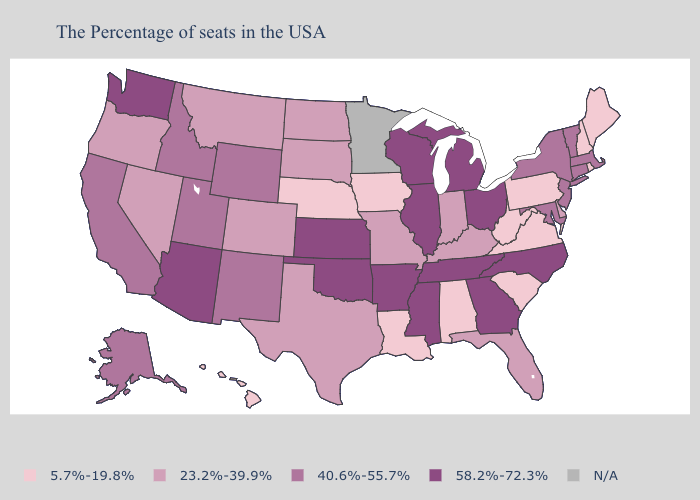Does Wyoming have the lowest value in the USA?
Give a very brief answer. No. Name the states that have a value in the range 5.7%-19.8%?
Give a very brief answer. Maine, Rhode Island, New Hampshire, Pennsylvania, Virginia, South Carolina, West Virginia, Alabama, Louisiana, Iowa, Nebraska, Hawaii. Among the states that border Arkansas , does Louisiana have the lowest value?
Short answer required. Yes. Is the legend a continuous bar?
Keep it brief. No. What is the value of Wisconsin?
Quick response, please. 58.2%-72.3%. What is the value of Utah?
Write a very short answer. 40.6%-55.7%. Name the states that have a value in the range N/A?
Short answer required. Minnesota. What is the value of Maine?
Concise answer only. 5.7%-19.8%. Which states have the highest value in the USA?
Concise answer only. North Carolina, Ohio, Georgia, Michigan, Tennessee, Wisconsin, Illinois, Mississippi, Arkansas, Kansas, Oklahoma, Arizona, Washington. Which states have the lowest value in the MidWest?
Be succinct. Iowa, Nebraska. Name the states that have a value in the range 23.2%-39.9%?
Quick response, please. Delaware, Florida, Kentucky, Indiana, Missouri, Texas, South Dakota, North Dakota, Colorado, Montana, Nevada, Oregon. Among the states that border Illinois , which have the highest value?
Quick response, please. Wisconsin. 